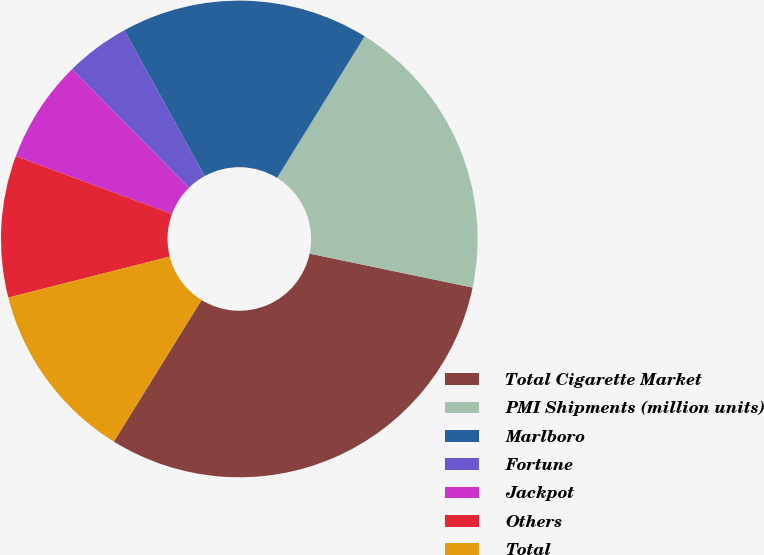<chart> <loc_0><loc_0><loc_500><loc_500><pie_chart><fcel>Total Cigarette Market<fcel>PMI Shipments (million units)<fcel>Marlboro<fcel>Fortune<fcel>Jackpot<fcel>Others<fcel>Total<nl><fcel>30.55%<fcel>19.45%<fcel>16.83%<fcel>4.36%<fcel>6.98%<fcel>9.6%<fcel>12.22%<nl></chart> 